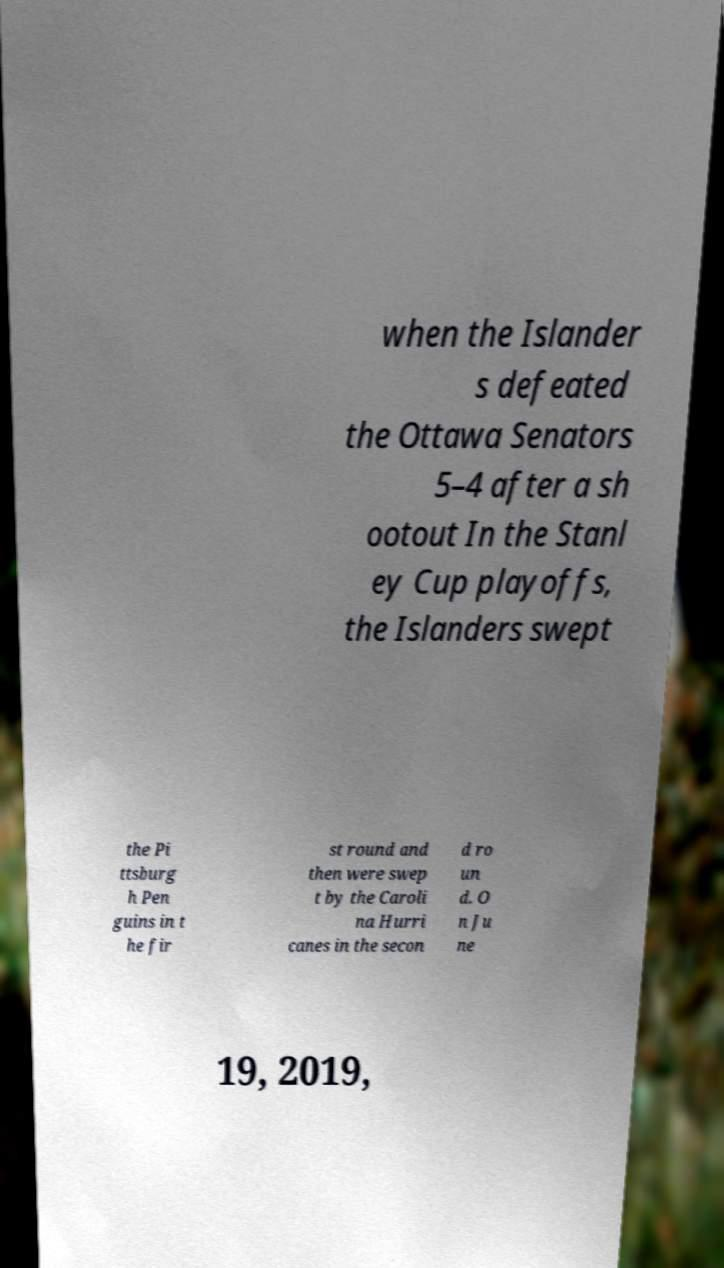What messages or text are displayed in this image? I need them in a readable, typed format. when the Islander s defeated the Ottawa Senators 5–4 after a sh ootout In the Stanl ey Cup playoffs, the Islanders swept the Pi ttsburg h Pen guins in t he fir st round and then were swep t by the Caroli na Hurri canes in the secon d ro un d. O n Ju ne 19, 2019, 